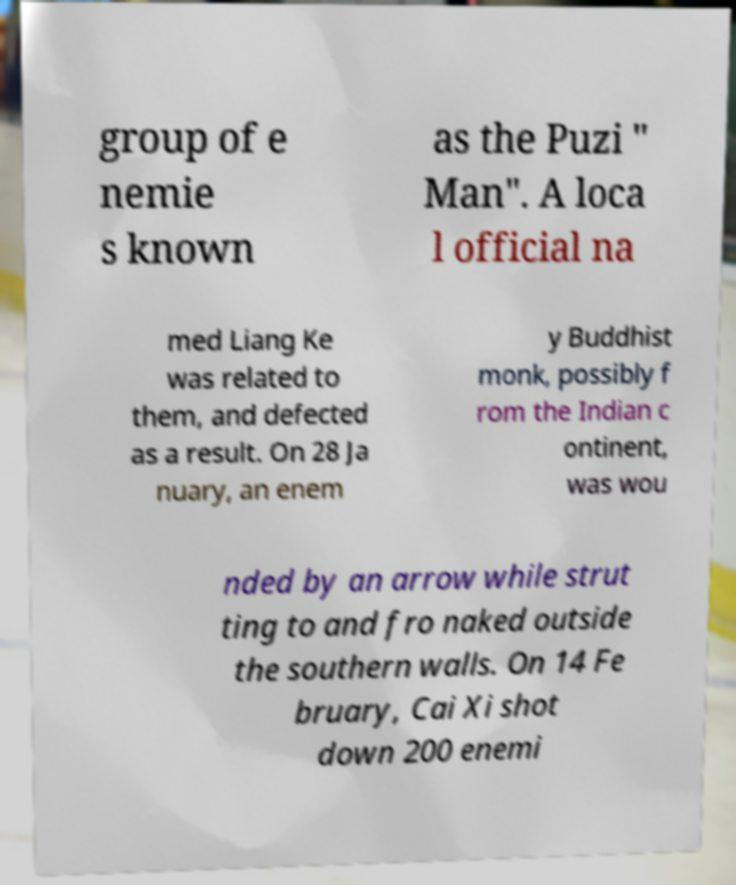I need the written content from this picture converted into text. Can you do that? group of e nemie s known as the Puzi " Man". A loca l official na med Liang Ke was related to them, and defected as a result. On 28 Ja nuary, an enem y Buddhist monk, possibly f rom the Indian c ontinent, was wou nded by an arrow while strut ting to and fro naked outside the southern walls. On 14 Fe bruary, Cai Xi shot down 200 enemi 